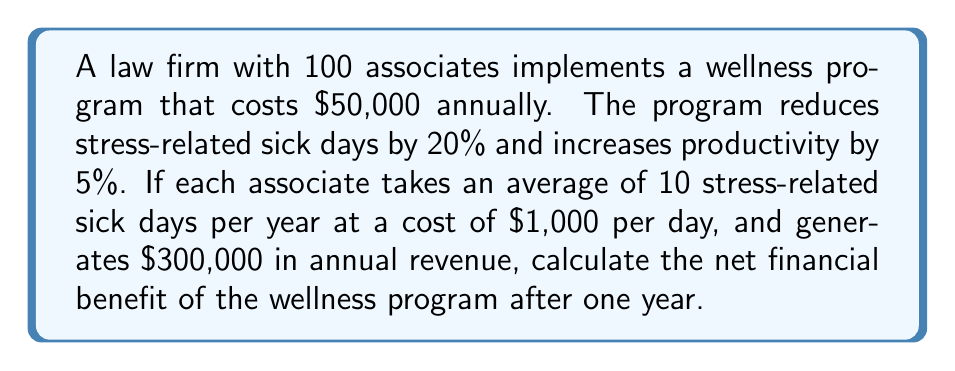Give your solution to this math problem. Let's break this down step-by-step:

1) Calculate the current cost of stress-related sick days:
   $$100 \text{ associates} \times 10 \text{ days} \times \$1,000 = \$1,000,000$$

2) Calculate the reduction in sick days cost after implementing the program:
   $$\$1,000,000 \times 20\% = \$200,000$$

3) Calculate the current annual revenue:
   $$100 \text{ associates} \times \$300,000 = \$30,000,000$$

4) Calculate the increase in revenue due to 5% productivity boost:
   $$\$30,000,000 \times 5\% = \$1,500,000$$

5) Calculate the total benefit:
   Sick day reduction + Revenue increase
   $$\$200,000 + \$1,500,000 = \$1,700,000$$

6) Calculate the net benefit by subtracting the cost of the program:
   $$\$1,700,000 - \$50,000 = \$1,650,000$$
Answer: $1,650,000 